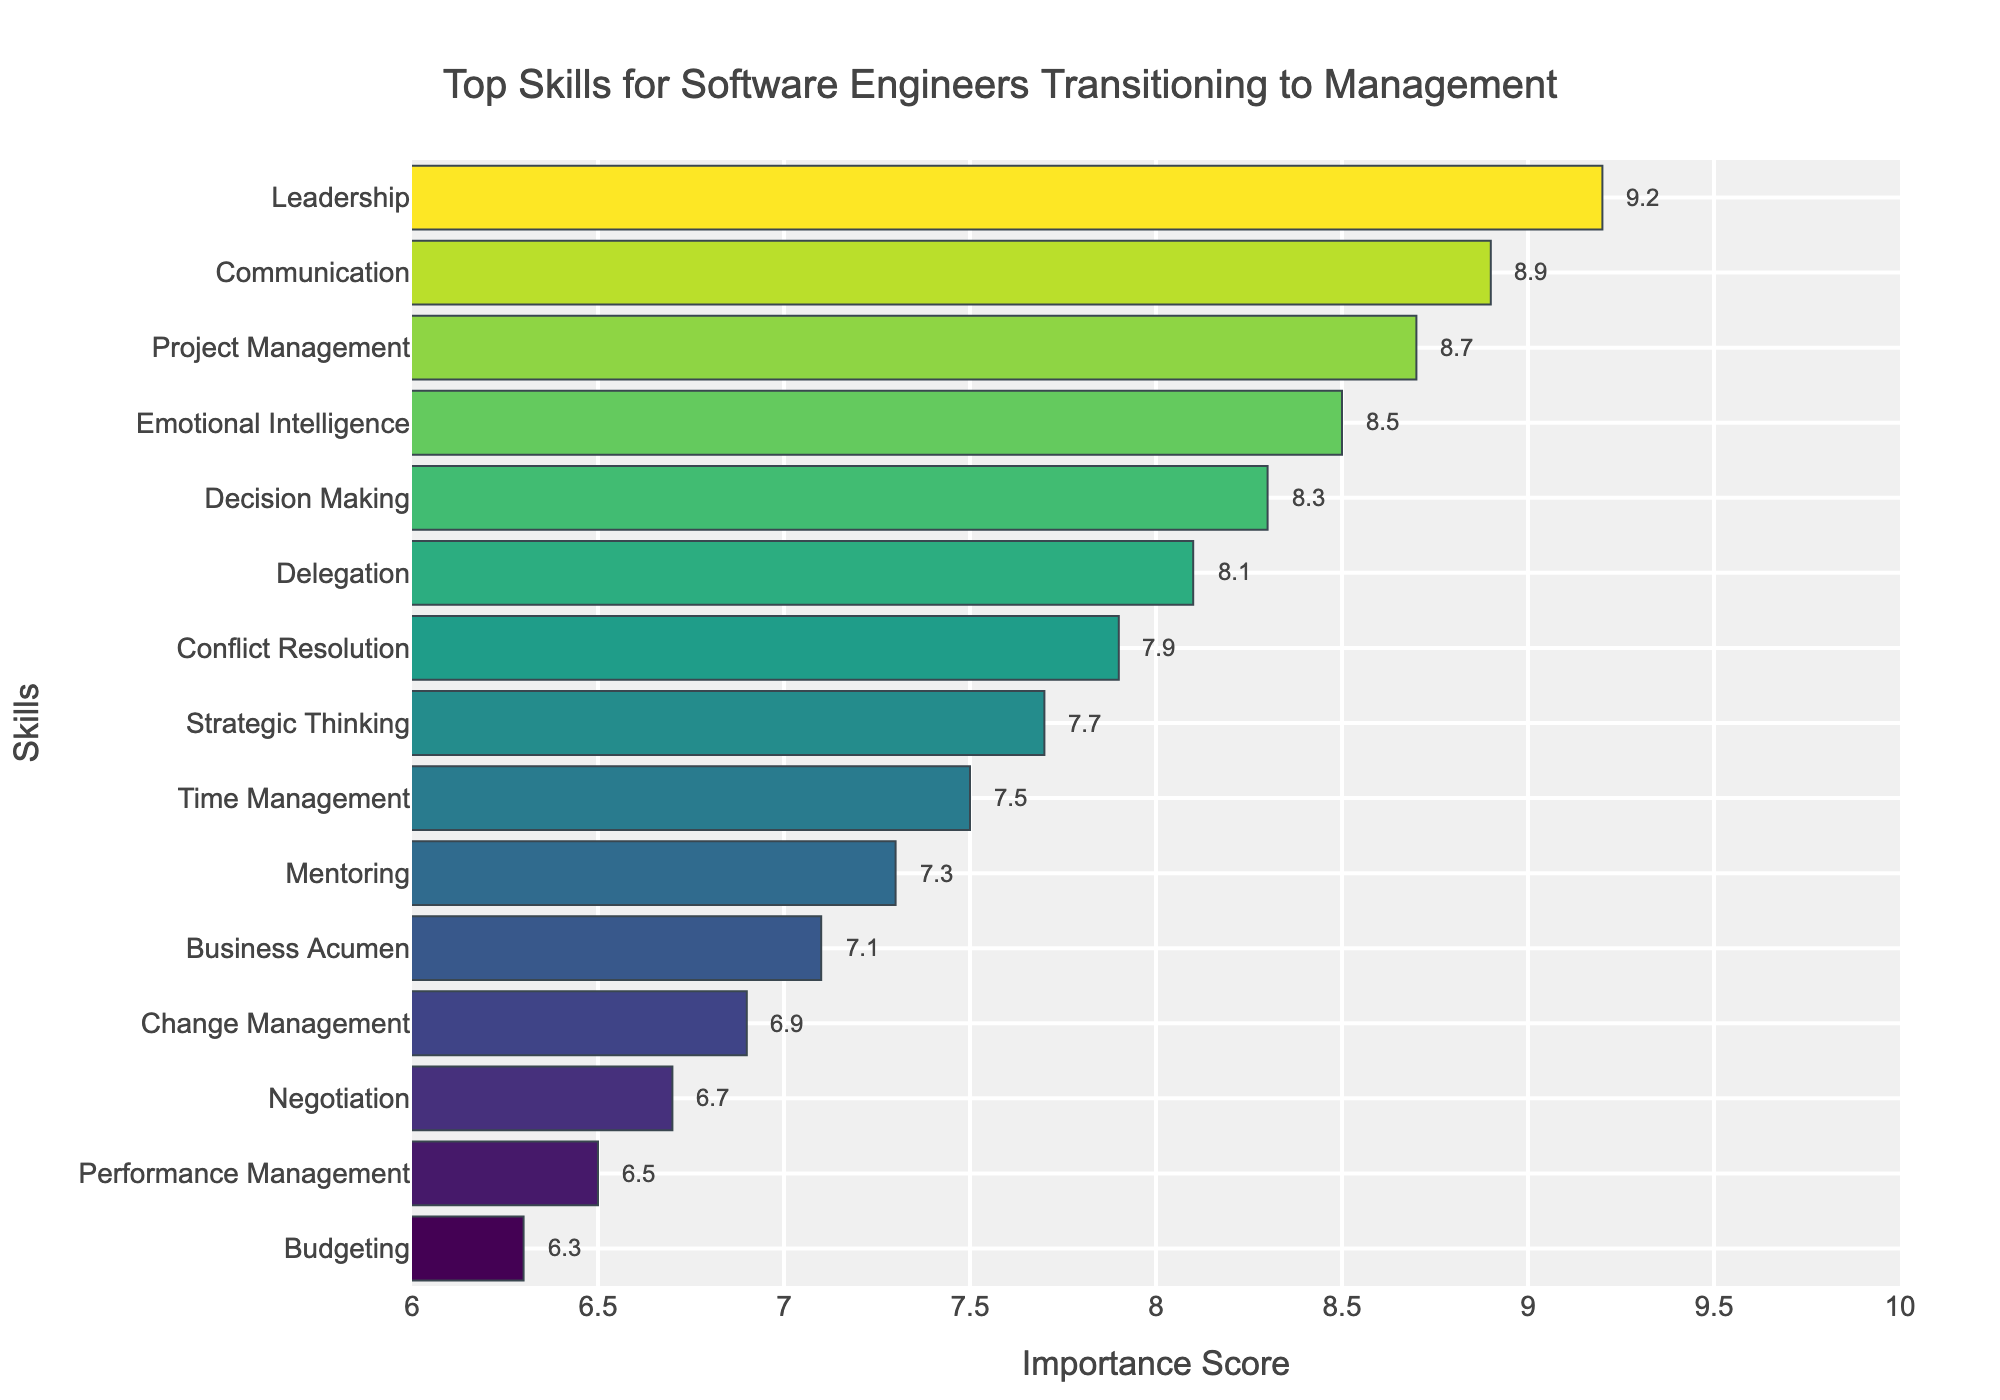Which skill received the highest importance score? The bar chart shows the importance scores of various skills, with the score for "Leadership" being the highest at 9.2.
Answer: Leadership What is the difference in importance score between Communication and Mentoring? Referring to the bar chart, Communication has a score of 8.9 and Mentoring has a score of 7.3. Calculating the difference: 8.9 - 7.3 = 1.6
Answer: 1.6 Which skill is considered more important, Decision Making or Strategic Thinking? According to the chart, Decision Making has an importance score of 8.3, while Strategic Thinking has a score of 7.7. Decision Making has a higher score.
Answer: Decision Making What is the average importance score of the top three skills? The top three skills are Leadership (9.2), Communication (8.9), and Project Management (8.7). To find the average: (9.2 + 8.9 + 8.7) / 3 = 8.93
Answer: 8.93 How many skills have an importance score of 8.0 or higher? From the chart, the skills with scores 8.0 or higher are Leadership, Communication, Project Management, Emotional Intelligence, Decision Making, and Delegation. There are 6 such skills.
Answer: 6 Which skill has the lowest importance score and what is it? The bar chart shows that Budgeting has the lowest importance score at 6.3.
Answer: Budgeting Which skill has a higher importance score, Time Management or Conflict Resolution? The bar chart shows that Conflict Resolution has a score of 7.9, while Time Management has a score of 7.5. Conflict Resolution is higher.
Answer: Conflict Resolution What is the combined importance score of Strategic Thinking and Business Acumen? From the chart, Strategic Thinking has a score of 7.7 and Business Acumen has a score of 7.1. Adding these together: 7.7 + 7.1 = 14.8
Answer: 14.8 What is the median importance score of all the skills? To find the median score, list the scores in ascending order and find the middle value. The scores are: 6.3, 6.5, 6.7, 6.9, 7.1, 7.3, 7.5, 7.7, 7.9, 8.1, 8.3, 8.5, 8.7, 8.9, 9.2. The median is 7.7.
Answer: 7.7 